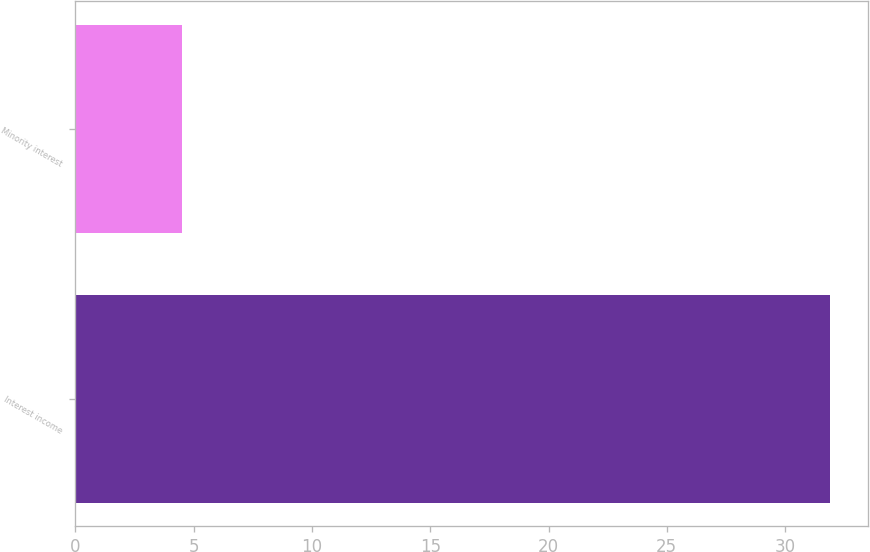<chart> <loc_0><loc_0><loc_500><loc_500><bar_chart><fcel>Interest income<fcel>Minority interest<nl><fcel>31.9<fcel>4.5<nl></chart> 